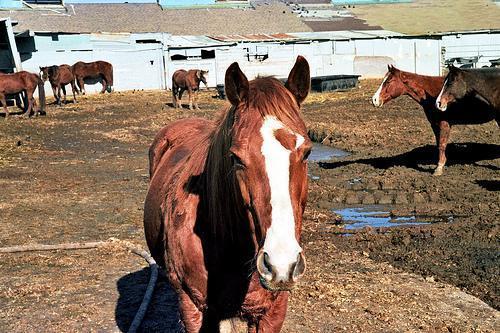How many horses are facing the camera?
Give a very brief answer. 1. 